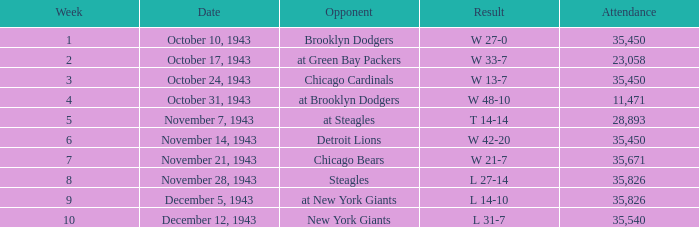What is the lowest attendance that has a week less than 4, and w 13-7 as the result? 35450.0. 